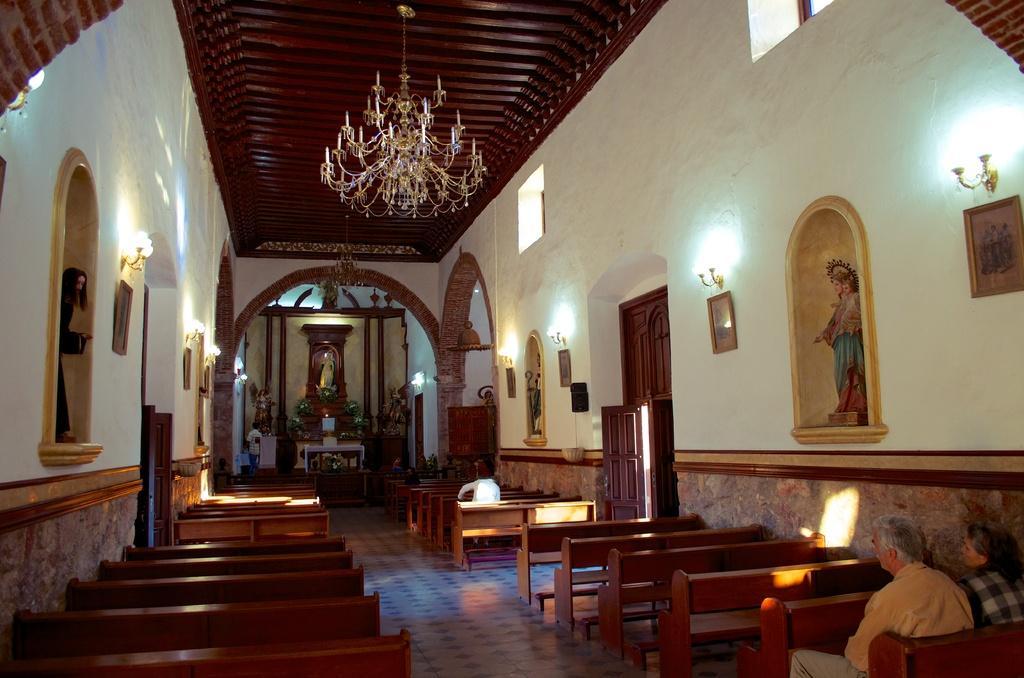In one or two sentences, can you explain what this image depicts? This picture is clicked inside the hall. In the center we can see the benches and we can see the group of persons sitting on the benches and the picture frames hanging on the wall and we can see the wall mounted lamps, sculptures of persons, wooden door, windows and there are some objects placed on the ground and we can see a person seems to be standing on the floor. In the background we can see the wall and many other objects. At the top there is a roof and a chandelier hanging on the roof. 